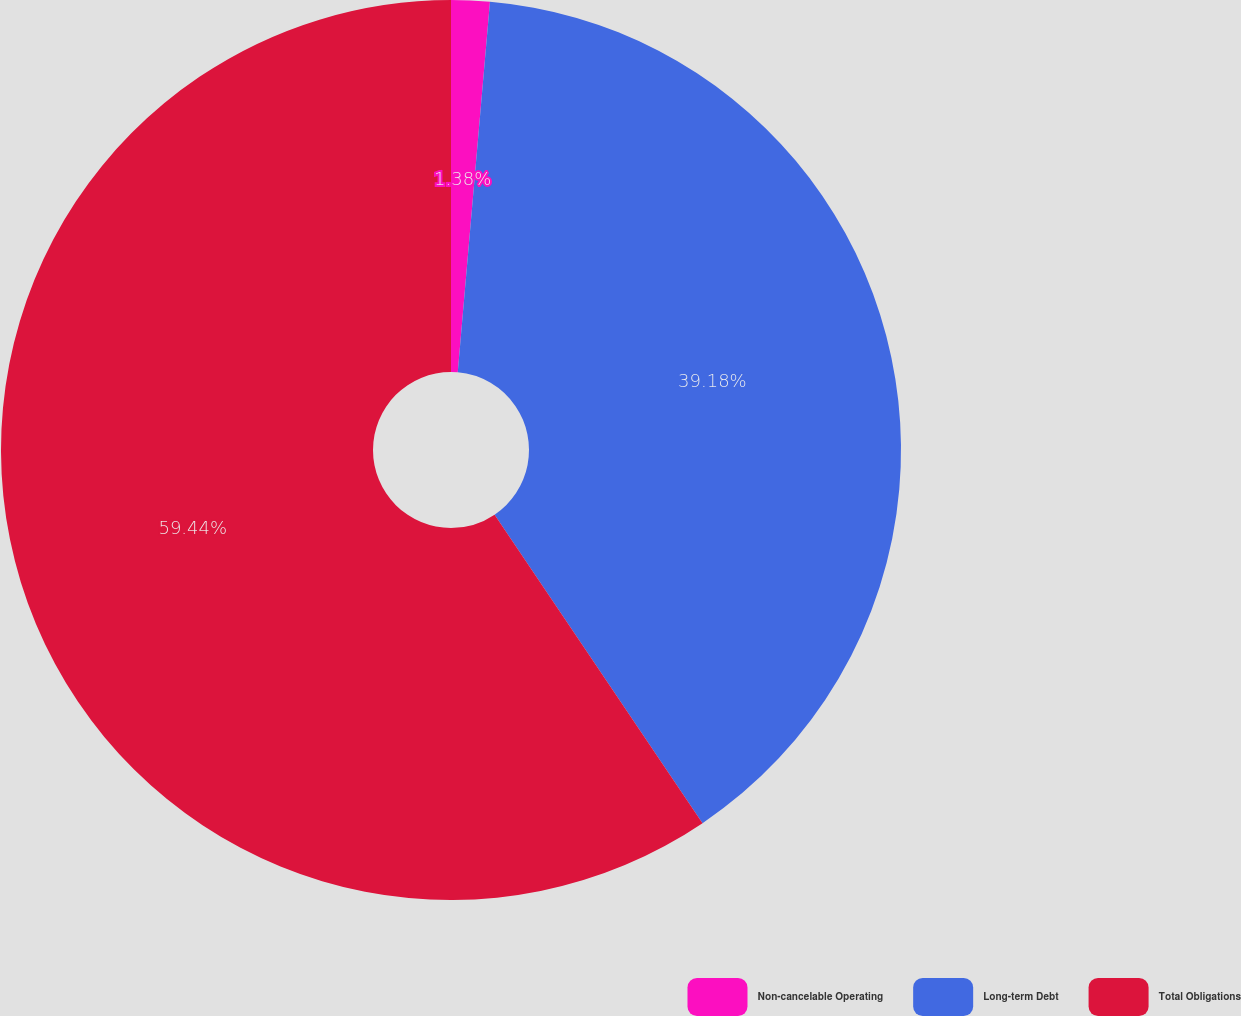Convert chart to OTSL. <chart><loc_0><loc_0><loc_500><loc_500><pie_chart><fcel>Non-cancelable Operating<fcel>Long-term Debt<fcel>Total Obligations<nl><fcel>1.38%<fcel>39.18%<fcel>59.44%<nl></chart> 